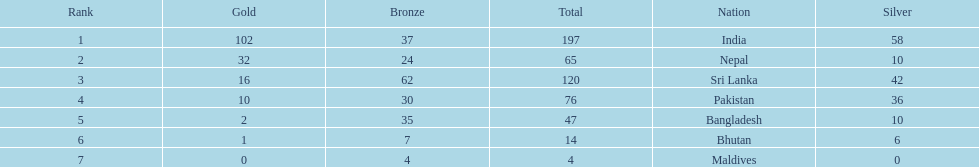How many gold medals were awarded between all 7 nations? 163. 